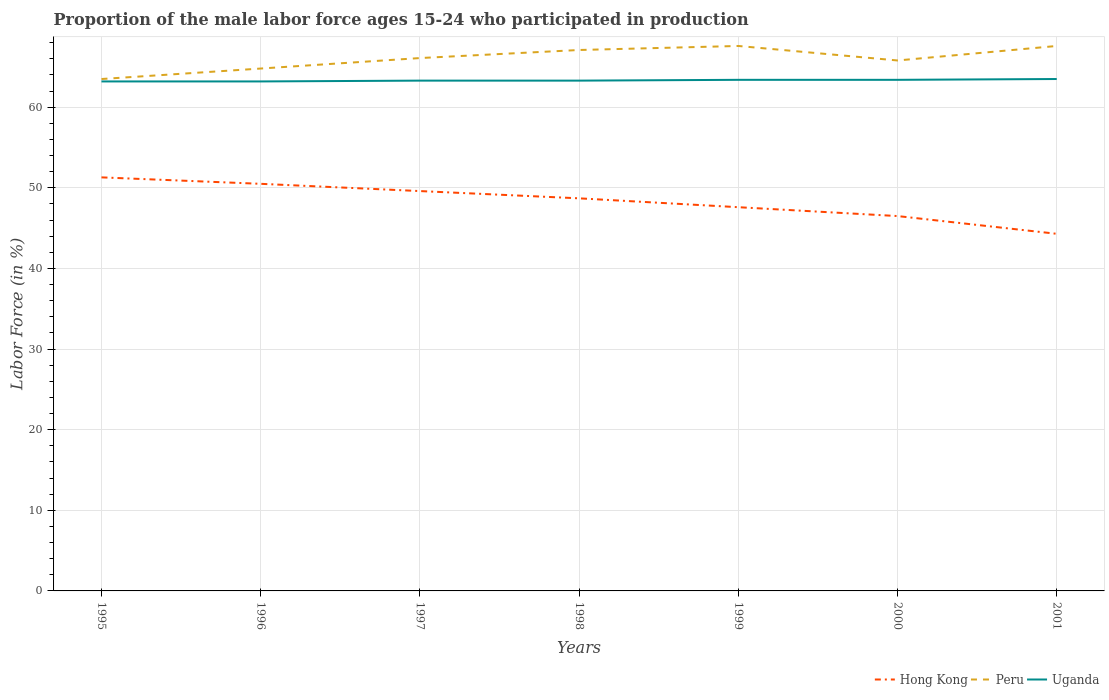How many different coloured lines are there?
Offer a very short reply. 3. Does the line corresponding to Hong Kong intersect with the line corresponding to Uganda?
Offer a very short reply. No. Is the number of lines equal to the number of legend labels?
Your response must be concise. Yes. Across all years, what is the maximum proportion of the male labor force who participated in production in Hong Kong?
Provide a short and direct response. 44.3. In which year was the proportion of the male labor force who participated in production in Peru maximum?
Provide a short and direct response. 1995. What is the total proportion of the male labor force who participated in production in Peru in the graph?
Your answer should be very brief. -1.3. What is the difference between the highest and the second highest proportion of the male labor force who participated in production in Hong Kong?
Provide a short and direct response. 7. What is the difference between the highest and the lowest proportion of the male labor force who participated in production in Peru?
Keep it short and to the point. 4. Is the proportion of the male labor force who participated in production in Uganda strictly greater than the proportion of the male labor force who participated in production in Hong Kong over the years?
Your response must be concise. No. How many lines are there?
Keep it short and to the point. 3. What is the difference between two consecutive major ticks on the Y-axis?
Offer a very short reply. 10. Are the values on the major ticks of Y-axis written in scientific E-notation?
Provide a short and direct response. No. How many legend labels are there?
Your response must be concise. 3. What is the title of the graph?
Provide a succinct answer. Proportion of the male labor force ages 15-24 who participated in production. What is the label or title of the X-axis?
Provide a short and direct response. Years. What is the Labor Force (in %) of Hong Kong in 1995?
Your answer should be very brief. 51.3. What is the Labor Force (in %) of Peru in 1995?
Keep it short and to the point. 63.5. What is the Labor Force (in %) of Uganda in 1995?
Your response must be concise. 63.2. What is the Labor Force (in %) of Hong Kong in 1996?
Keep it short and to the point. 50.5. What is the Labor Force (in %) in Peru in 1996?
Make the answer very short. 64.8. What is the Labor Force (in %) of Uganda in 1996?
Ensure brevity in your answer.  63.2. What is the Labor Force (in %) of Hong Kong in 1997?
Give a very brief answer. 49.6. What is the Labor Force (in %) in Peru in 1997?
Offer a terse response. 66.1. What is the Labor Force (in %) in Uganda in 1997?
Offer a very short reply. 63.3. What is the Labor Force (in %) in Hong Kong in 1998?
Make the answer very short. 48.7. What is the Labor Force (in %) of Peru in 1998?
Provide a succinct answer. 67.1. What is the Labor Force (in %) of Uganda in 1998?
Offer a very short reply. 63.3. What is the Labor Force (in %) of Hong Kong in 1999?
Provide a short and direct response. 47.6. What is the Labor Force (in %) in Peru in 1999?
Give a very brief answer. 67.6. What is the Labor Force (in %) in Uganda in 1999?
Your response must be concise. 63.4. What is the Labor Force (in %) in Hong Kong in 2000?
Give a very brief answer. 46.5. What is the Labor Force (in %) in Peru in 2000?
Provide a succinct answer. 65.8. What is the Labor Force (in %) in Uganda in 2000?
Your response must be concise. 63.4. What is the Labor Force (in %) in Hong Kong in 2001?
Your answer should be compact. 44.3. What is the Labor Force (in %) of Peru in 2001?
Give a very brief answer. 67.6. What is the Labor Force (in %) of Uganda in 2001?
Keep it short and to the point. 63.5. Across all years, what is the maximum Labor Force (in %) of Hong Kong?
Offer a terse response. 51.3. Across all years, what is the maximum Labor Force (in %) in Peru?
Your answer should be compact. 67.6. Across all years, what is the maximum Labor Force (in %) in Uganda?
Make the answer very short. 63.5. Across all years, what is the minimum Labor Force (in %) in Hong Kong?
Give a very brief answer. 44.3. Across all years, what is the minimum Labor Force (in %) in Peru?
Provide a short and direct response. 63.5. Across all years, what is the minimum Labor Force (in %) in Uganda?
Your answer should be very brief. 63.2. What is the total Labor Force (in %) in Hong Kong in the graph?
Offer a very short reply. 338.5. What is the total Labor Force (in %) of Peru in the graph?
Ensure brevity in your answer.  462.5. What is the total Labor Force (in %) in Uganda in the graph?
Your answer should be very brief. 443.3. What is the difference between the Labor Force (in %) of Hong Kong in 1995 and that in 1998?
Provide a succinct answer. 2.6. What is the difference between the Labor Force (in %) of Peru in 1995 and that in 1998?
Your response must be concise. -3.6. What is the difference between the Labor Force (in %) in Uganda in 1995 and that in 1998?
Your answer should be very brief. -0.1. What is the difference between the Labor Force (in %) of Hong Kong in 1995 and that in 2000?
Keep it short and to the point. 4.8. What is the difference between the Labor Force (in %) of Peru in 1995 and that in 2000?
Offer a terse response. -2.3. What is the difference between the Labor Force (in %) in Uganda in 1995 and that in 2000?
Your response must be concise. -0.2. What is the difference between the Labor Force (in %) of Hong Kong in 1995 and that in 2001?
Provide a succinct answer. 7. What is the difference between the Labor Force (in %) in Peru in 1995 and that in 2001?
Ensure brevity in your answer.  -4.1. What is the difference between the Labor Force (in %) of Peru in 1996 and that in 1997?
Your answer should be very brief. -1.3. What is the difference between the Labor Force (in %) of Uganda in 1996 and that in 1997?
Your response must be concise. -0.1. What is the difference between the Labor Force (in %) of Peru in 1996 and that in 1998?
Your response must be concise. -2.3. What is the difference between the Labor Force (in %) of Uganda in 1996 and that in 1998?
Your answer should be compact. -0.1. What is the difference between the Labor Force (in %) of Hong Kong in 1996 and that in 1999?
Make the answer very short. 2.9. What is the difference between the Labor Force (in %) in Peru in 1996 and that in 1999?
Provide a short and direct response. -2.8. What is the difference between the Labor Force (in %) in Uganda in 1996 and that in 1999?
Your answer should be very brief. -0.2. What is the difference between the Labor Force (in %) of Hong Kong in 1996 and that in 2000?
Provide a succinct answer. 4. What is the difference between the Labor Force (in %) of Peru in 1996 and that in 2000?
Your response must be concise. -1. What is the difference between the Labor Force (in %) in Uganda in 1996 and that in 2000?
Make the answer very short. -0.2. What is the difference between the Labor Force (in %) in Hong Kong in 1996 and that in 2001?
Make the answer very short. 6.2. What is the difference between the Labor Force (in %) in Peru in 1996 and that in 2001?
Your response must be concise. -2.8. What is the difference between the Labor Force (in %) of Hong Kong in 1997 and that in 1998?
Provide a succinct answer. 0.9. What is the difference between the Labor Force (in %) of Peru in 1997 and that in 1998?
Your answer should be compact. -1. What is the difference between the Labor Force (in %) of Peru in 1997 and that in 1999?
Provide a short and direct response. -1.5. What is the difference between the Labor Force (in %) of Uganda in 1997 and that in 1999?
Your response must be concise. -0.1. What is the difference between the Labor Force (in %) of Hong Kong in 1997 and that in 2000?
Provide a succinct answer. 3.1. What is the difference between the Labor Force (in %) in Peru in 1997 and that in 2000?
Your response must be concise. 0.3. What is the difference between the Labor Force (in %) of Uganda in 1997 and that in 2000?
Give a very brief answer. -0.1. What is the difference between the Labor Force (in %) in Peru in 1997 and that in 2001?
Give a very brief answer. -1.5. What is the difference between the Labor Force (in %) in Uganda in 1997 and that in 2001?
Offer a terse response. -0.2. What is the difference between the Labor Force (in %) of Hong Kong in 1998 and that in 1999?
Keep it short and to the point. 1.1. What is the difference between the Labor Force (in %) of Hong Kong in 1998 and that in 2001?
Provide a succinct answer. 4.4. What is the difference between the Labor Force (in %) of Peru in 1998 and that in 2001?
Provide a short and direct response. -0.5. What is the difference between the Labor Force (in %) of Peru in 1999 and that in 2000?
Provide a short and direct response. 1.8. What is the difference between the Labor Force (in %) in Uganda in 1999 and that in 2000?
Keep it short and to the point. 0. What is the difference between the Labor Force (in %) in Peru in 1999 and that in 2001?
Ensure brevity in your answer.  0. What is the difference between the Labor Force (in %) of Uganda in 1999 and that in 2001?
Ensure brevity in your answer.  -0.1. What is the difference between the Labor Force (in %) of Uganda in 2000 and that in 2001?
Offer a very short reply. -0.1. What is the difference between the Labor Force (in %) in Hong Kong in 1995 and the Labor Force (in %) in Peru in 1997?
Offer a terse response. -14.8. What is the difference between the Labor Force (in %) of Hong Kong in 1995 and the Labor Force (in %) of Uganda in 1997?
Make the answer very short. -12. What is the difference between the Labor Force (in %) of Peru in 1995 and the Labor Force (in %) of Uganda in 1997?
Make the answer very short. 0.2. What is the difference between the Labor Force (in %) in Hong Kong in 1995 and the Labor Force (in %) in Peru in 1998?
Make the answer very short. -15.8. What is the difference between the Labor Force (in %) of Hong Kong in 1995 and the Labor Force (in %) of Peru in 1999?
Make the answer very short. -16.3. What is the difference between the Labor Force (in %) in Peru in 1995 and the Labor Force (in %) in Uganda in 1999?
Your response must be concise. 0.1. What is the difference between the Labor Force (in %) of Hong Kong in 1995 and the Labor Force (in %) of Peru in 2000?
Your response must be concise. -14.5. What is the difference between the Labor Force (in %) of Hong Kong in 1995 and the Labor Force (in %) of Uganda in 2000?
Your answer should be compact. -12.1. What is the difference between the Labor Force (in %) of Peru in 1995 and the Labor Force (in %) of Uganda in 2000?
Your response must be concise. 0.1. What is the difference between the Labor Force (in %) in Hong Kong in 1995 and the Labor Force (in %) in Peru in 2001?
Ensure brevity in your answer.  -16.3. What is the difference between the Labor Force (in %) in Hong Kong in 1996 and the Labor Force (in %) in Peru in 1997?
Your response must be concise. -15.6. What is the difference between the Labor Force (in %) of Hong Kong in 1996 and the Labor Force (in %) of Uganda in 1997?
Make the answer very short. -12.8. What is the difference between the Labor Force (in %) of Hong Kong in 1996 and the Labor Force (in %) of Peru in 1998?
Your answer should be compact. -16.6. What is the difference between the Labor Force (in %) of Hong Kong in 1996 and the Labor Force (in %) of Uganda in 1998?
Provide a short and direct response. -12.8. What is the difference between the Labor Force (in %) of Peru in 1996 and the Labor Force (in %) of Uganda in 1998?
Keep it short and to the point. 1.5. What is the difference between the Labor Force (in %) in Hong Kong in 1996 and the Labor Force (in %) in Peru in 1999?
Your answer should be very brief. -17.1. What is the difference between the Labor Force (in %) in Hong Kong in 1996 and the Labor Force (in %) in Peru in 2000?
Provide a succinct answer. -15.3. What is the difference between the Labor Force (in %) in Peru in 1996 and the Labor Force (in %) in Uganda in 2000?
Give a very brief answer. 1.4. What is the difference between the Labor Force (in %) of Hong Kong in 1996 and the Labor Force (in %) of Peru in 2001?
Offer a terse response. -17.1. What is the difference between the Labor Force (in %) in Hong Kong in 1997 and the Labor Force (in %) in Peru in 1998?
Provide a short and direct response. -17.5. What is the difference between the Labor Force (in %) of Hong Kong in 1997 and the Labor Force (in %) of Uganda in 1998?
Your answer should be compact. -13.7. What is the difference between the Labor Force (in %) in Peru in 1997 and the Labor Force (in %) in Uganda in 1998?
Offer a terse response. 2.8. What is the difference between the Labor Force (in %) in Peru in 1997 and the Labor Force (in %) in Uganda in 1999?
Offer a terse response. 2.7. What is the difference between the Labor Force (in %) in Hong Kong in 1997 and the Labor Force (in %) in Peru in 2000?
Ensure brevity in your answer.  -16.2. What is the difference between the Labor Force (in %) in Peru in 1997 and the Labor Force (in %) in Uganda in 2000?
Your answer should be very brief. 2.7. What is the difference between the Labor Force (in %) in Hong Kong in 1997 and the Labor Force (in %) in Peru in 2001?
Make the answer very short. -18. What is the difference between the Labor Force (in %) of Peru in 1997 and the Labor Force (in %) of Uganda in 2001?
Your response must be concise. 2.6. What is the difference between the Labor Force (in %) of Hong Kong in 1998 and the Labor Force (in %) of Peru in 1999?
Provide a short and direct response. -18.9. What is the difference between the Labor Force (in %) in Hong Kong in 1998 and the Labor Force (in %) in Uganda in 1999?
Offer a very short reply. -14.7. What is the difference between the Labor Force (in %) in Peru in 1998 and the Labor Force (in %) in Uganda in 1999?
Keep it short and to the point. 3.7. What is the difference between the Labor Force (in %) of Hong Kong in 1998 and the Labor Force (in %) of Peru in 2000?
Offer a very short reply. -17.1. What is the difference between the Labor Force (in %) in Hong Kong in 1998 and the Labor Force (in %) in Uganda in 2000?
Your answer should be very brief. -14.7. What is the difference between the Labor Force (in %) in Hong Kong in 1998 and the Labor Force (in %) in Peru in 2001?
Keep it short and to the point. -18.9. What is the difference between the Labor Force (in %) in Hong Kong in 1998 and the Labor Force (in %) in Uganda in 2001?
Your answer should be very brief. -14.8. What is the difference between the Labor Force (in %) in Peru in 1998 and the Labor Force (in %) in Uganda in 2001?
Your answer should be very brief. 3.6. What is the difference between the Labor Force (in %) of Hong Kong in 1999 and the Labor Force (in %) of Peru in 2000?
Make the answer very short. -18.2. What is the difference between the Labor Force (in %) in Hong Kong in 1999 and the Labor Force (in %) in Uganda in 2000?
Your answer should be very brief. -15.8. What is the difference between the Labor Force (in %) of Hong Kong in 1999 and the Labor Force (in %) of Uganda in 2001?
Your response must be concise. -15.9. What is the difference between the Labor Force (in %) in Hong Kong in 2000 and the Labor Force (in %) in Peru in 2001?
Ensure brevity in your answer.  -21.1. What is the difference between the Labor Force (in %) in Hong Kong in 2000 and the Labor Force (in %) in Uganda in 2001?
Your answer should be compact. -17. What is the difference between the Labor Force (in %) of Peru in 2000 and the Labor Force (in %) of Uganda in 2001?
Provide a short and direct response. 2.3. What is the average Labor Force (in %) of Hong Kong per year?
Your response must be concise. 48.36. What is the average Labor Force (in %) of Peru per year?
Give a very brief answer. 66.07. What is the average Labor Force (in %) of Uganda per year?
Your answer should be compact. 63.33. In the year 1995, what is the difference between the Labor Force (in %) of Hong Kong and Labor Force (in %) of Peru?
Give a very brief answer. -12.2. In the year 1996, what is the difference between the Labor Force (in %) of Hong Kong and Labor Force (in %) of Peru?
Your response must be concise. -14.3. In the year 1996, what is the difference between the Labor Force (in %) in Hong Kong and Labor Force (in %) in Uganda?
Ensure brevity in your answer.  -12.7. In the year 1997, what is the difference between the Labor Force (in %) of Hong Kong and Labor Force (in %) of Peru?
Offer a very short reply. -16.5. In the year 1997, what is the difference between the Labor Force (in %) in Hong Kong and Labor Force (in %) in Uganda?
Give a very brief answer. -13.7. In the year 1997, what is the difference between the Labor Force (in %) in Peru and Labor Force (in %) in Uganda?
Ensure brevity in your answer.  2.8. In the year 1998, what is the difference between the Labor Force (in %) of Hong Kong and Labor Force (in %) of Peru?
Ensure brevity in your answer.  -18.4. In the year 1998, what is the difference between the Labor Force (in %) of Hong Kong and Labor Force (in %) of Uganda?
Your answer should be very brief. -14.6. In the year 1999, what is the difference between the Labor Force (in %) of Hong Kong and Labor Force (in %) of Uganda?
Offer a very short reply. -15.8. In the year 2000, what is the difference between the Labor Force (in %) of Hong Kong and Labor Force (in %) of Peru?
Provide a short and direct response. -19.3. In the year 2000, what is the difference between the Labor Force (in %) of Hong Kong and Labor Force (in %) of Uganda?
Give a very brief answer. -16.9. In the year 2000, what is the difference between the Labor Force (in %) of Peru and Labor Force (in %) of Uganda?
Your response must be concise. 2.4. In the year 2001, what is the difference between the Labor Force (in %) of Hong Kong and Labor Force (in %) of Peru?
Provide a short and direct response. -23.3. In the year 2001, what is the difference between the Labor Force (in %) of Hong Kong and Labor Force (in %) of Uganda?
Give a very brief answer. -19.2. In the year 2001, what is the difference between the Labor Force (in %) of Peru and Labor Force (in %) of Uganda?
Your answer should be very brief. 4.1. What is the ratio of the Labor Force (in %) of Hong Kong in 1995 to that in 1996?
Offer a very short reply. 1.02. What is the ratio of the Labor Force (in %) of Peru in 1995 to that in 1996?
Make the answer very short. 0.98. What is the ratio of the Labor Force (in %) in Uganda in 1995 to that in 1996?
Offer a very short reply. 1. What is the ratio of the Labor Force (in %) of Hong Kong in 1995 to that in 1997?
Give a very brief answer. 1.03. What is the ratio of the Labor Force (in %) in Peru in 1995 to that in 1997?
Keep it short and to the point. 0.96. What is the ratio of the Labor Force (in %) in Hong Kong in 1995 to that in 1998?
Ensure brevity in your answer.  1.05. What is the ratio of the Labor Force (in %) in Peru in 1995 to that in 1998?
Your answer should be compact. 0.95. What is the ratio of the Labor Force (in %) of Uganda in 1995 to that in 1998?
Offer a terse response. 1. What is the ratio of the Labor Force (in %) of Hong Kong in 1995 to that in 1999?
Provide a short and direct response. 1.08. What is the ratio of the Labor Force (in %) in Peru in 1995 to that in 1999?
Ensure brevity in your answer.  0.94. What is the ratio of the Labor Force (in %) in Uganda in 1995 to that in 1999?
Offer a terse response. 1. What is the ratio of the Labor Force (in %) in Hong Kong in 1995 to that in 2000?
Your response must be concise. 1.1. What is the ratio of the Labor Force (in %) in Hong Kong in 1995 to that in 2001?
Offer a terse response. 1.16. What is the ratio of the Labor Force (in %) in Peru in 1995 to that in 2001?
Ensure brevity in your answer.  0.94. What is the ratio of the Labor Force (in %) in Hong Kong in 1996 to that in 1997?
Give a very brief answer. 1.02. What is the ratio of the Labor Force (in %) in Peru in 1996 to that in 1997?
Your answer should be very brief. 0.98. What is the ratio of the Labor Force (in %) of Uganda in 1996 to that in 1997?
Your answer should be compact. 1. What is the ratio of the Labor Force (in %) in Peru in 1996 to that in 1998?
Keep it short and to the point. 0.97. What is the ratio of the Labor Force (in %) in Hong Kong in 1996 to that in 1999?
Provide a short and direct response. 1.06. What is the ratio of the Labor Force (in %) of Peru in 1996 to that in 1999?
Provide a short and direct response. 0.96. What is the ratio of the Labor Force (in %) in Uganda in 1996 to that in 1999?
Give a very brief answer. 1. What is the ratio of the Labor Force (in %) of Hong Kong in 1996 to that in 2000?
Provide a short and direct response. 1.09. What is the ratio of the Labor Force (in %) of Hong Kong in 1996 to that in 2001?
Keep it short and to the point. 1.14. What is the ratio of the Labor Force (in %) in Peru in 1996 to that in 2001?
Give a very brief answer. 0.96. What is the ratio of the Labor Force (in %) in Uganda in 1996 to that in 2001?
Your answer should be very brief. 1. What is the ratio of the Labor Force (in %) in Hong Kong in 1997 to that in 1998?
Keep it short and to the point. 1.02. What is the ratio of the Labor Force (in %) of Peru in 1997 to that in 1998?
Provide a succinct answer. 0.99. What is the ratio of the Labor Force (in %) of Uganda in 1997 to that in 1998?
Provide a short and direct response. 1. What is the ratio of the Labor Force (in %) of Hong Kong in 1997 to that in 1999?
Ensure brevity in your answer.  1.04. What is the ratio of the Labor Force (in %) in Peru in 1997 to that in 1999?
Your answer should be very brief. 0.98. What is the ratio of the Labor Force (in %) of Hong Kong in 1997 to that in 2000?
Your answer should be compact. 1.07. What is the ratio of the Labor Force (in %) in Hong Kong in 1997 to that in 2001?
Provide a succinct answer. 1.12. What is the ratio of the Labor Force (in %) of Peru in 1997 to that in 2001?
Offer a very short reply. 0.98. What is the ratio of the Labor Force (in %) of Uganda in 1997 to that in 2001?
Provide a short and direct response. 1. What is the ratio of the Labor Force (in %) of Hong Kong in 1998 to that in 1999?
Your answer should be compact. 1.02. What is the ratio of the Labor Force (in %) of Peru in 1998 to that in 1999?
Keep it short and to the point. 0.99. What is the ratio of the Labor Force (in %) in Uganda in 1998 to that in 1999?
Offer a terse response. 1. What is the ratio of the Labor Force (in %) in Hong Kong in 1998 to that in 2000?
Provide a succinct answer. 1.05. What is the ratio of the Labor Force (in %) of Peru in 1998 to that in 2000?
Your answer should be compact. 1.02. What is the ratio of the Labor Force (in %) of Hong Kong in 1998 to that in 2001?
Ensure brevity in your answer.  1.1. What is the ratio of the Labor Force (in %) of Uganda in 1998 to that in 2001?
Provide a succinct answer. 1. What is the ratio of the Labor Force (in %) in Hong Kong in 1999 to that in 2000?
Give a very brief answer. 1.02. What is the ratio of the Labor Force (in %) of Peru in 1999 to that in 2000?
Give a very brief answer. 1.03. What is the ratio of the Labor Force (in %) of Uganda in 1999 to that in 2000?
Ensure brevity in your answer.  1. What is the ratio of the Labor Force (in %) in Hong Kong in 1999 to that in 2001?
Provide a short and direct response. 1.07. What is the ratio of the Labor Force (in %) in Uganda in 1999 to that in 2001?
Make the answer very short. 1. What is the ratio of the Labor Force (in %) in Hong Kong in 2000 to that in 2001?
Give a very brief answer. 1.05. What is the ratio of the Labor Force (in %) in Peru in 2000 to that in 2001?
Offer a very short reply. 0.97. What is the difference between the highest and the lowest Labor Force (in %) of Hong Kong?
Offer a terse response. 7. What is the difference between the highest and the lowest Labor Force (in %) in Uganda?
Your response must be concise. 0.3. 